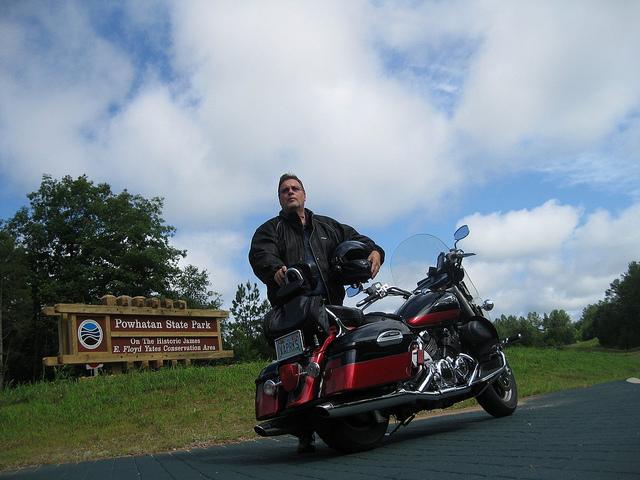How many bikes are there?
Concise answer only. 1. How many bikes are in the picture?
Quick response, please. 1. What is the name of the State Park in the photo?
Write a very short answer. Powhatan state park. Is there a large audience?
Concise answer only. No. Is the motorcycle facing left or right?
Write a very short answer. Right. How long is the rider's hair?
Answer briefly. Short. How many men are shown?
Short answer required. 1. Is the motorcycle in motion?
Give a very brief answer. No. Is the man in the picture having fun?
Short answer required. Yes. Is the man harnessed?
Short answer required. No. How many bike are here?
Be succinct. 1. How many bikes in the shot?
Quick response, please. 1. Has this vehicle been to space?
Keep it brief. No. Do these people have the proper head safety equipment on?
Keep it brief. No. Is the racer going fast or slow?
Answer briefly. Slow. Does he have a helmet?
Short answer required. Yes. Is the photo in black and white?
Be succinct. No. How many different kinds of two wheeled transportation are depicted in the photo?
Short answer required. 1. Where was the race at?
Give a very brief answer. Powhatan state park. Is the bike a moped?
Give a very brief answer. No. What brand of motorcycle is that?
Concise answer only. Harley. What are the last four numbers of the license plate number?
Concise answer only. Parks. Is he too big to ride this motorcycle?
Give a very brief answer. No. How many motorcycles are there?
Quick response, please. 1. What is the accent color on the motorcycle?
Keep it brief. Red. What color are the motorcycle riders' uniforms?
Give a very brief answer. Black. Is this a color photo?
Quick response, please. Yes. What color is the bike?
Keep it brief. Red and black. Is he going on a sightseeing tour?
Quick response, please. Yes. Is he wearing a helmet?
Quick response, please. No. 